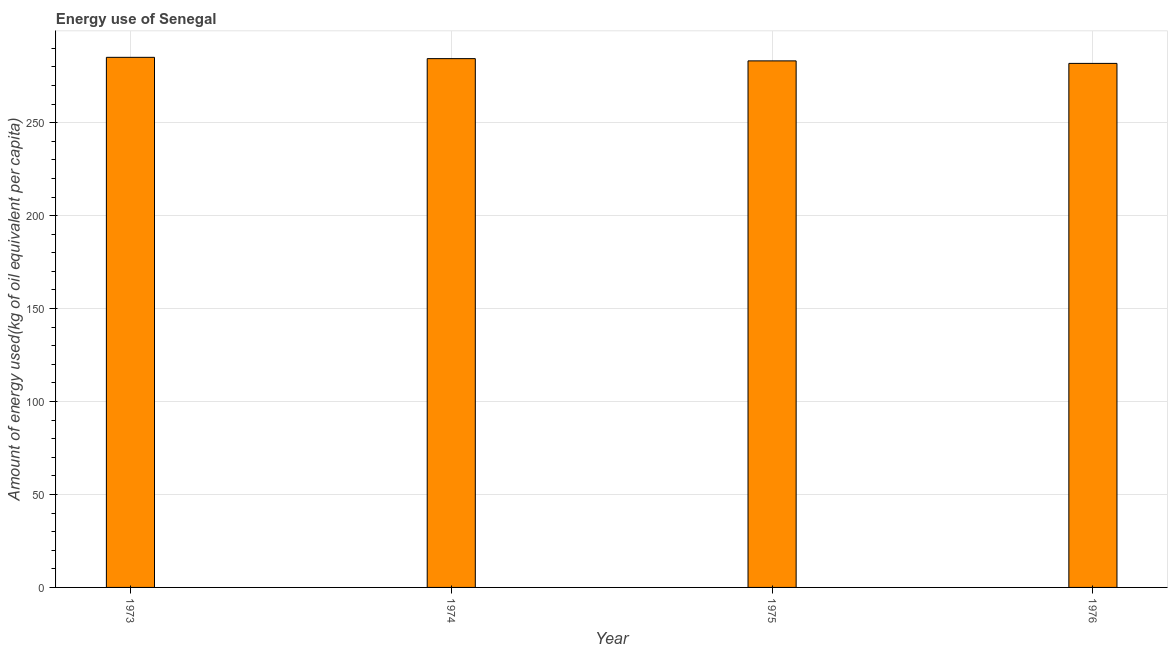Does the graph contain any zero values?
Provide a succinct answer. No. Does the graph contain grids?
Give a very brief answer. Yes. What is the title of the graph?
Provide a short and direct response. Energy use of Senegal. What is the label or title of the X-axis?
Ensure brevity in your answer.  Year. What is the label or title of the Y-axis?
Your answer should be compact. Amount of energy used(kg of oil equivalent per capita). What is the amount of energy used in 1975?
Provide a short and direct response. 283.24. Across all years, what is the maximum amount of energy used?
Your answer should be very brief. 285.15. Across all years, what is the minimum amount of energy used?
Make the answer very short. 281.88. In which year was the amount of energy used maximum?
Your answer should be very brief. 1973. In which year was the amount of energy used minimum?
Your response must be concise. 1976. What is the sum of the amount of energy used?
Make the answer very short. 1134.7. What is the difference between the amount of energy used in 1974 and 1975?
Offer a terse response. 1.21. What is the average amount of energy used per year?
Keep it short and to the point. 283.68. What is the median amount of energy used?
Provide a short and direct response. 283.84. In how many years, is the amount of energy used greater than 40 kg?
Your response must be concise. 4. Is the amount of energy used in 1973 less than that in 1974?
Your response must be concise. No. Is the difference between the amount of energy used in 1974 and 1976 greater than the difference between any two years?
Your response must be concise. No. What is the difference between the highest and the second highest amount of energy used?
Offer a terse response. 0.7. Is the sum of the amount of energy used in 1975 and 1976 greater than the maximum amount of energy used across all years?
Give a very brief answer. Yes. What is the difference between the highest and the lowest amount of energy used?
Your answer should be very brief. 3.27. In how many years, is the amount of energy used greater than the average amount of energy used taken over all years?
Your answer should be compact. 2. How many bars are there?
Offer a very short reply. 4. Are all the bars in the graph horizontal?
Make the answer very short. No. What is the difference between two consecutive major ticks on the Y-axis?
Your response must be concise. 50. Are the values on the major ticks of Y-axis written in scientific E-notation?
Your answer should be compact. No. What is the Amount of energy used(kg of oil equivalent per capita) in 1973?
Provide a succinct answer. 285.15. What is the Amount of energy used(kg of oil equivalent per capita) in 1974?
Your response must be concise. 284.44. What is the Amount of energy used(kg of oil equivalent per capita) in 1975?
Offer a terse response. 283.24. What is the Amount of energy used(kg of oil equivalent per capita) in 1976?
Your response must be concise. 281.88. What is the difference between the Amount of energy used(kg of oil equivalent per capita) in 1973 and 1974?
Your answer should be very brief. 0.7. What is the difference between the Amount of energy used(kg of oil equivalent per capita) in 1973 and 1975?
Provide a succinct answer. 1.91. What is the difference between the Amount of energy used(kg of oil equivalent per capita) in 1973 and 1976?
Offer a terse response. 3.27. What is the difference between the Amount of energy used(kg of oil equivalent per capita) in 1974 and 1975?
Give a very brief answer. 1.21. What is the difference between the Amount of energy used(kg of oil equivalent per capita) in 1974 and 1976?
Ensure brevity in your answer.  2.57. What is the difference between the Amount of energy used(kg of oil equivalent per capita) in 1975 and 1976?
Give a very brief answer. 1.36. What is the ratio of the Amount of energy used(kg of oil equivalent per capita) in 1973 to that in 1974?
Provide a succinct answer. 1. What is the ratio of the Amount of energy used(kg of oil equivalent per capita) in 1973 to that in 1975?
Your answer should be very brief. 1.01. What is the ratio of the Amount of energy used(kg of oil equivalent per capita) in 1974 to that in 1975?
Ensure brevity in your answer.  1. 